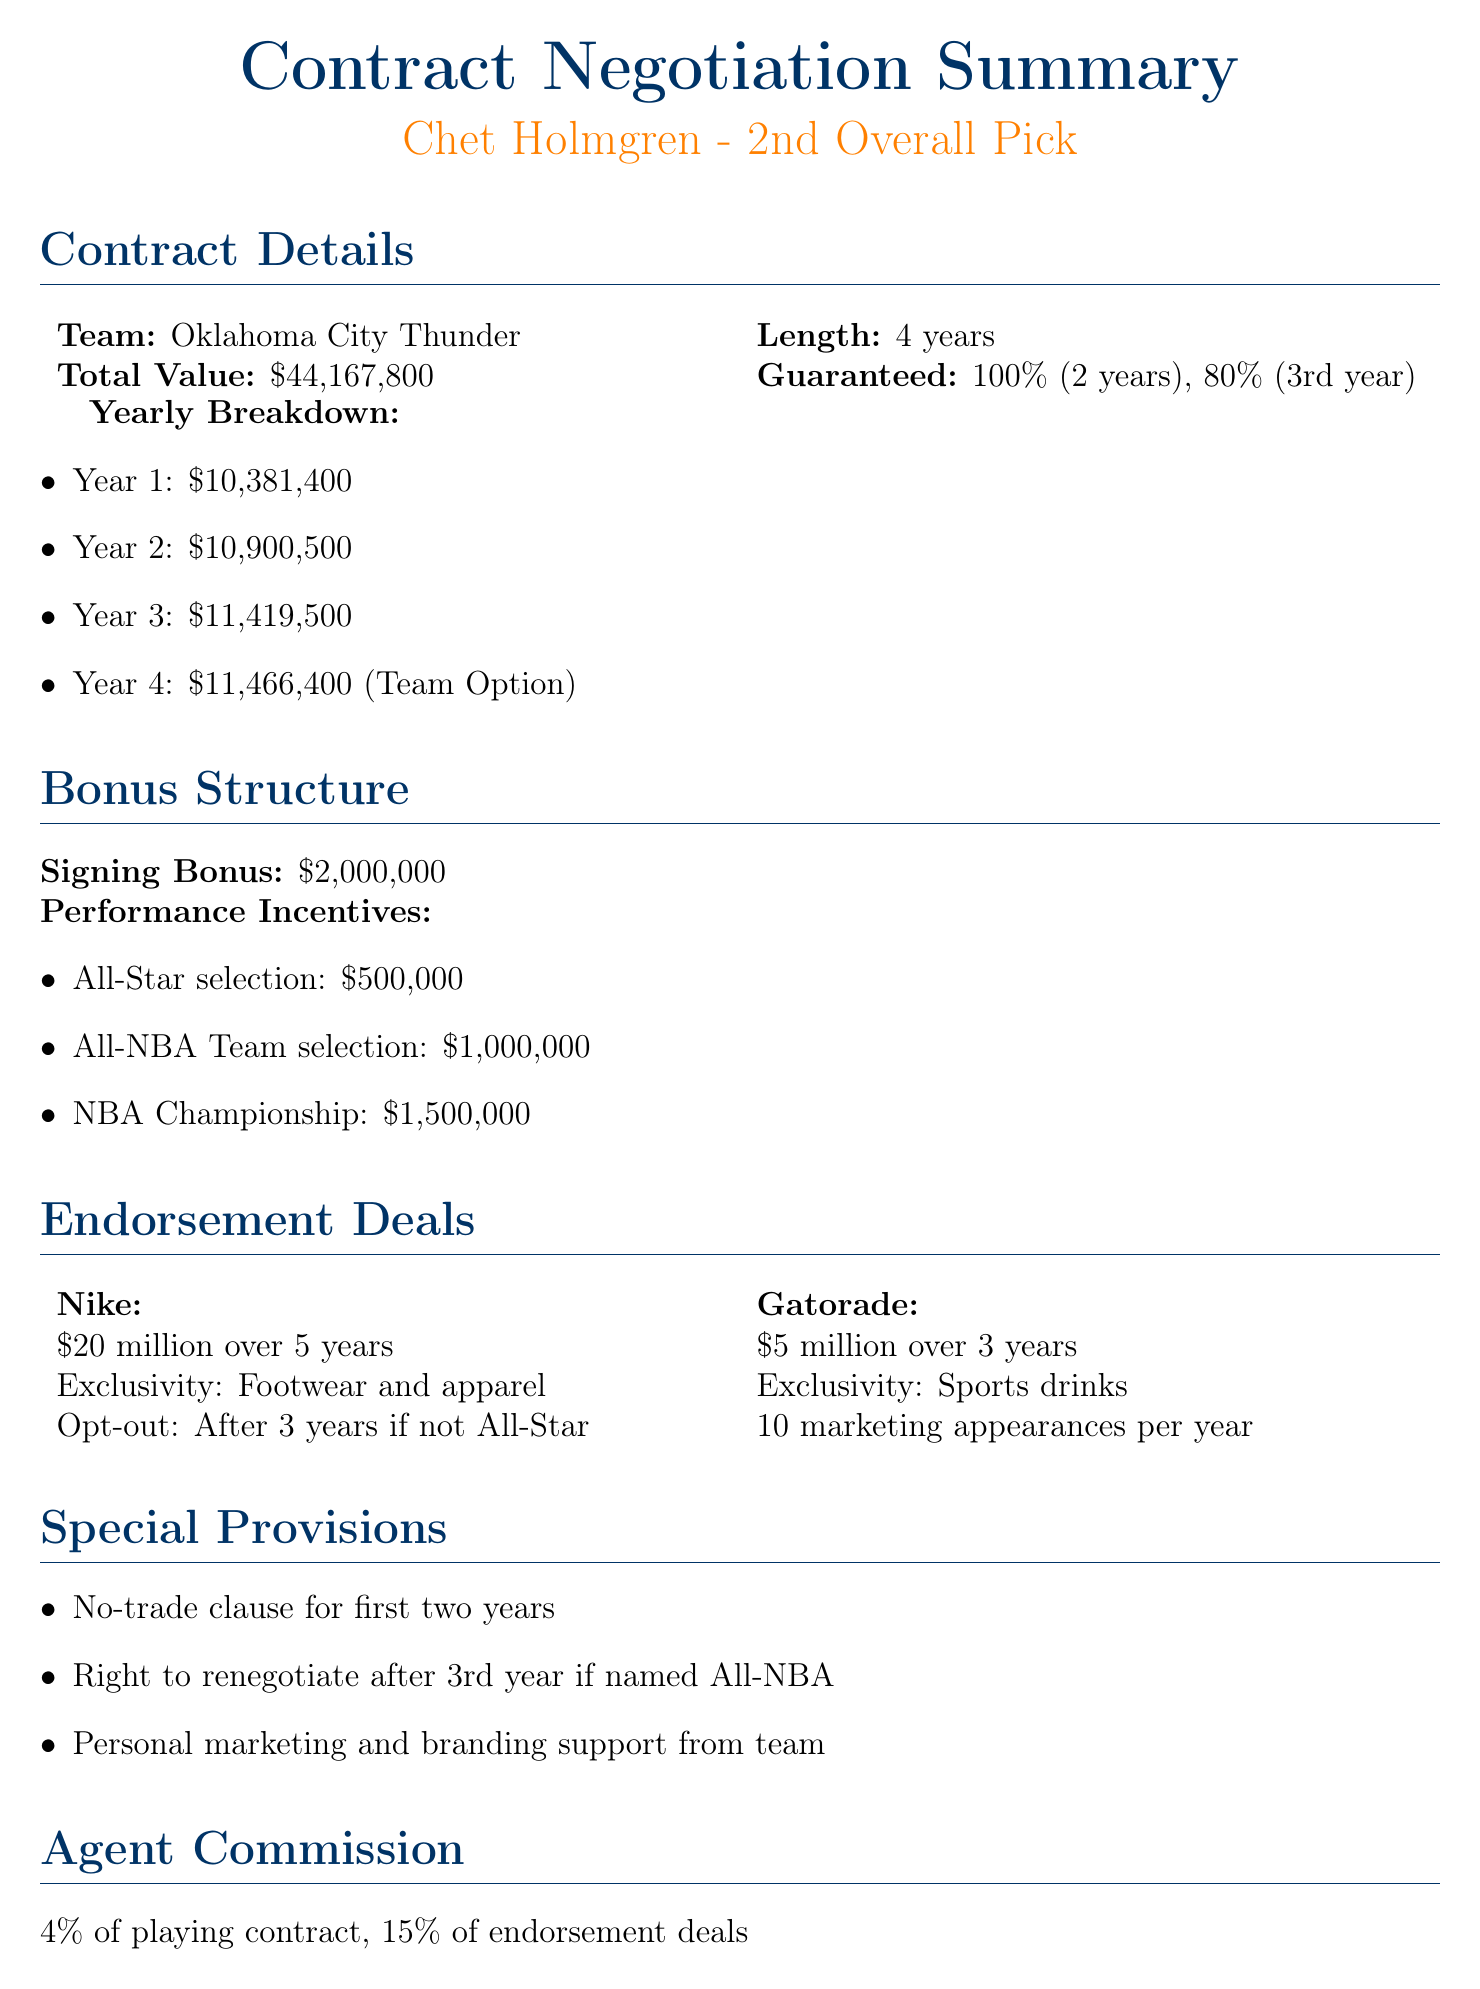What is the name of the client? The document states the client's name as Chet Holmgren.
Answer: Chet Holmgren What is the total value of the contract? The total value listed in the contract details is $44,167,800.
Answer: $44,167,800 How many years is the contract length? The contract details indicate that the length is 4 years.
Answer: 4 years What is the signing bonus amount? The document specifies the signing bonus as $2,000,000.
Answer: $2,000,000 What franchise does the client play for? According to the document, the client plays for the Oklahoma City Thunder.
Answer: Oklahoma City Thunder What percentage of the contract is guaranteed for the first two years? The document mentions that 100% of the contract is guaranteed for the first two years.
Answer: 100% Which performance incentive provides the highest bonus? The highest bonus listed for a performance incentive is for the NBA Championship, which is $1,500,000.
Answer: $1,500,000 What is the agent's commission for endorsement deals? The document states the agent's commission for endorsement deals is 15%.
Answer: 15% What special provision allows for a renegotiation of the contract? The right to renegotiate after the 3rd year if named All-NBA is a special provision mentioned.
Answer: Right to renegotiate after 3rd year if named All-NBA What is the market analysis trend regarding versatile big men? The document states that the league trends indicate an increasing value for versatile big men.
Answer: Increasing value for versatile big men 